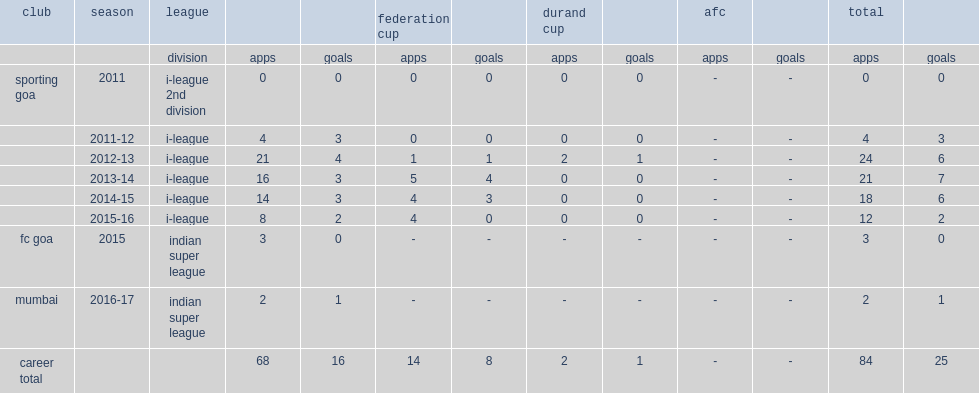Which club did victorino play in i-league in the 2011-12 season? Sporting goa. 